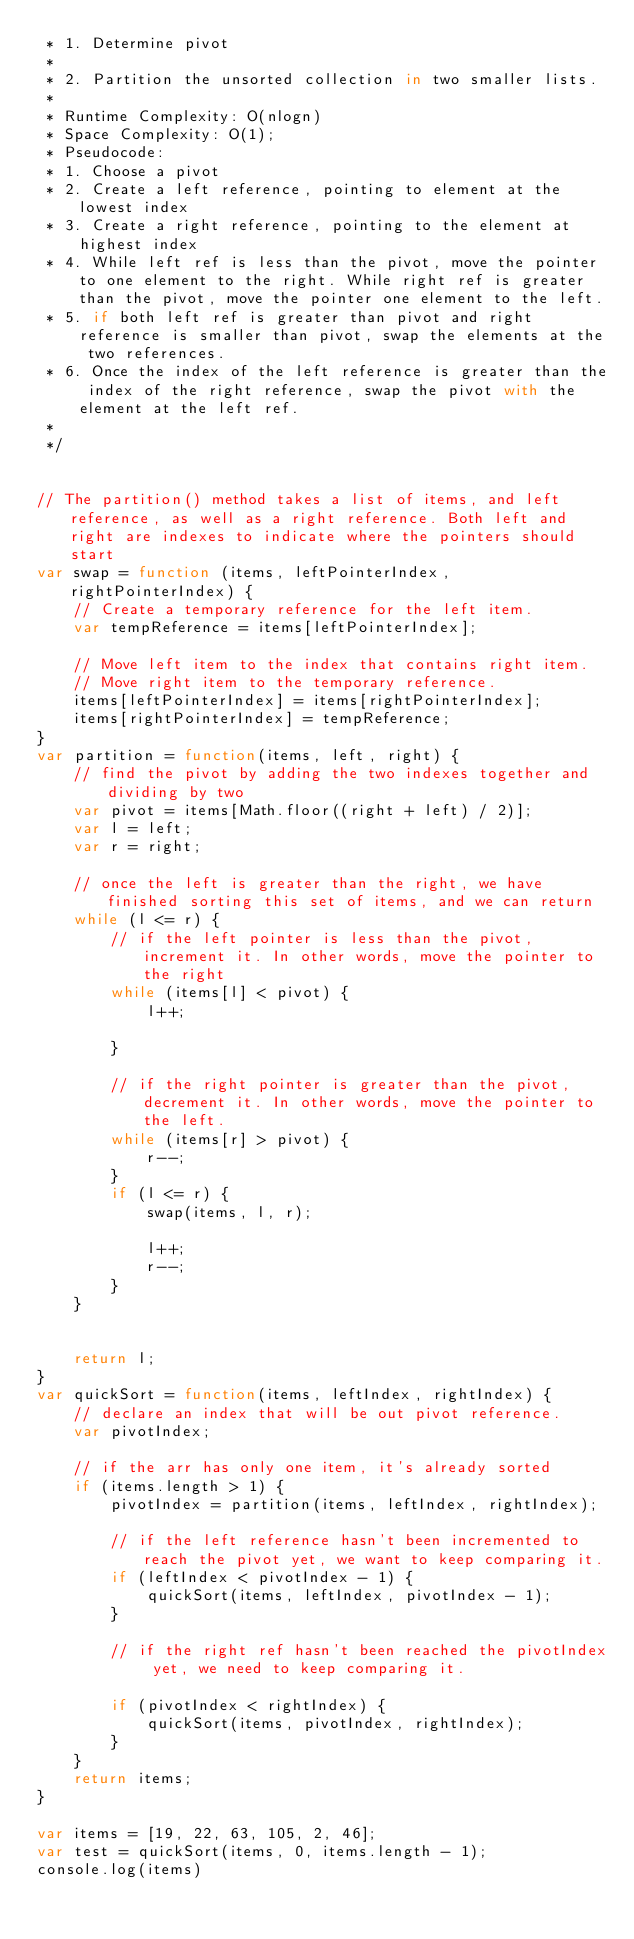Convert code to text. <code><loc_0><loc_0><loc_500><loc_500><_JavaScript_> * 1. Determine pivot 
 * 
 * 2. Partition the unsorted collection in two smaller lists. 
 * 
 * Runtime Complexity: O(nlogn)
 * Space Complexity: O(1);
 * Pseudocode: 
 * 1. Choose a pivot 
 * 2. Create a left reference, pointing to element at the lowest index 
 * 3. Create a right reference, pointing to the element at highest index 
 * 4. While left ref is less than the pivot, move the pointer to one element to the right. While right ref is greater than the pivot, move the pointer one element to the left. 
 * 5. if both left ref is greater than pivot and right reference is smaller than pivot, swap the elements at the two references. 
 * 6. Once the index of the left reference is greater than the index of the right reference, swap the pivot with the element at the left ref. 
 * 
 */


// The partition() method takes a list of items, and left reference, as well as a right reference. Both left and right are indexes to indicate where the pointers should start 
var swap = function (items, leftPointerIndex, rightPointerIndex) {
    // Create a temporary reference for the left item.
    var tempReference = items[leftPointerIndex];

    // Move left item to the index that contains right item.
    // Move right item to the temporary reference.
    items[leftPointerIndex] = items[rightPointerIndex];
    items[rightPointerIndex] = tempReference;
}
var partition = function(items, left, right) { 
    // find the pivot by adding the two indexes together and dividing by two 
    var pivot = items[Math.floor((right + left) / 2)]; 
    var l = left;
    var r = right; 

    // once the left is greater than the right, we have finished sorting this set of items, and we can return 
    while (l <= r) { 
        // if the left pointer is less than the pivot, increment it. In other words, move the pointer to the right 
        while (items[l] < pivot) { 
            l++; 

        }

        // if the right pointer is greater than the pivot, decrement it. In other words, move the pointer to the left. 
        while (items[r] > pivot) { 
            r--; 
        }
        if (l <= r) {
            swap(items, l, r);

            l++;
            r--;
        }
    }

    
    return l;
}
var quickSort = function(items, leftIndex, rightIndex) { 
    // declare an index that will be out pivot reference. 
    var pivotIndex; 

    // if the arr has only one item, it's already sorted
    if (items.length > 1) { 
        pivotIndex = partition(items, leftIndex, rightIndex);

        // if the left reference hasn't been incremented to reach the pivot yet, we want to keep comparing it. 
        if (leftIndex < pivotIndex - 1) { 
            quickSort(items, leftIndex, pivotIndex - 1);
        }

        // if the right ref hasn't been reached the pivotIndex yet, we need to keep comparing it. 

        if (pivotIndex < rightIndex) { 
            quickSort(items, pivotIndex, rightIndex);
        }
    }
    return items;
}

var items = [19, 22, 63, 105, 2, 46];
var test = quickSort(items, 0, items.length - 1);
console.log(items)</code> 